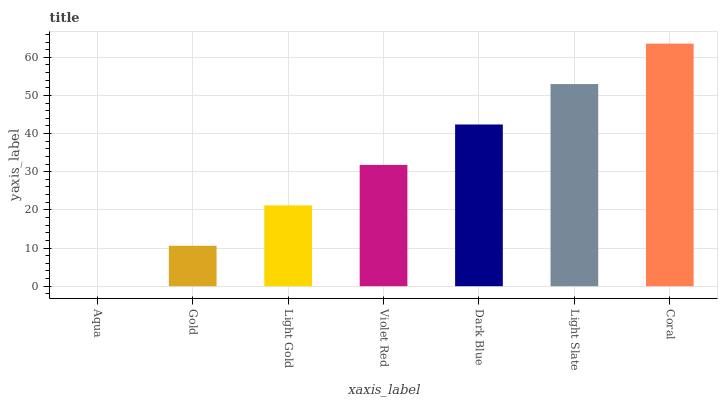Is Aqua the minimum?
Answer yes or no. Yes. Is Coral the maximum?
Answer yes or no. Yes. Is Gold the minimum?
Answer yes or no. No. Is Gold the maximum?
Answer yes or no. No. Is Gold greater than Aqua?
Answer yes or no. Yes. Is Aqua less than Gold?
Answer yes or no. Yes. Is Aqua greater than Gold?
Answer yes or no. No. Is Gold less than Aqua?
Answer yes or no. No. Is Violet Red the high median?
Answer yes or no. Yes. Is Violet Red the low median?
Answer yes or no. Yes. Is Coral the high median?
Answer yes or no. No. Is Dark Blue the low median?
Answer yes or no. No. 